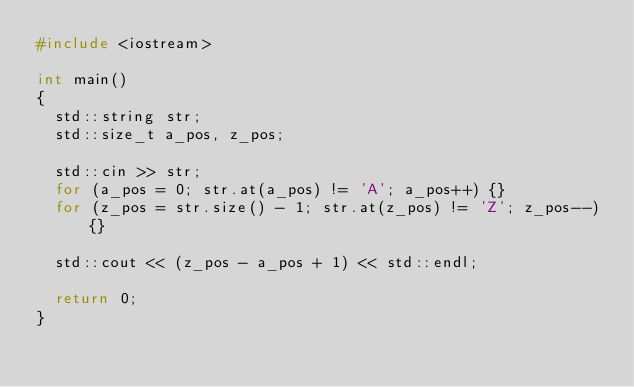<code> <loc_0><loc_0><loc_500><loc_500><_C++_>#include <iostream>

int main()
{
	std::string str;
	std::size_t a_pos, z_pos;

	std::cin >> str;
	for (a_pos = 0; str.at(a_pos) != 'A'; a_pos++) {}
	for (z_pos = str.size() - 1; str.at(z_pos) != 'Z'; z_pos--) {}

	std::cout << (z_pos - a_pos + 1) << std::endl;

	return 0;
}</code> 